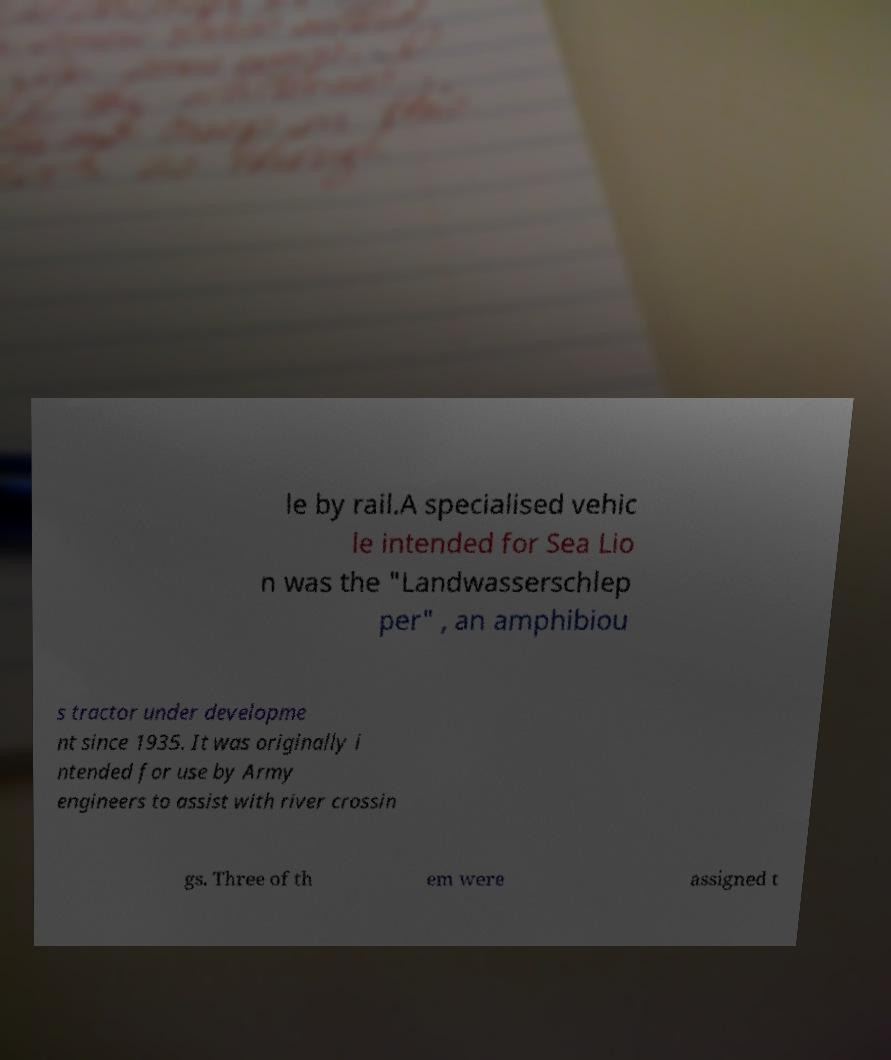Could you assist in decoding the text presented in this image and type it out clearly? le by rail.A specialised vehic le intended for Sea Lio n was the "Landwasserschlep per" , an amphibiou s tractor under developme nt since 1935. It was originally i ntended for use by Army engineers to assist with river crossin gs. Three of th em were assigned t 